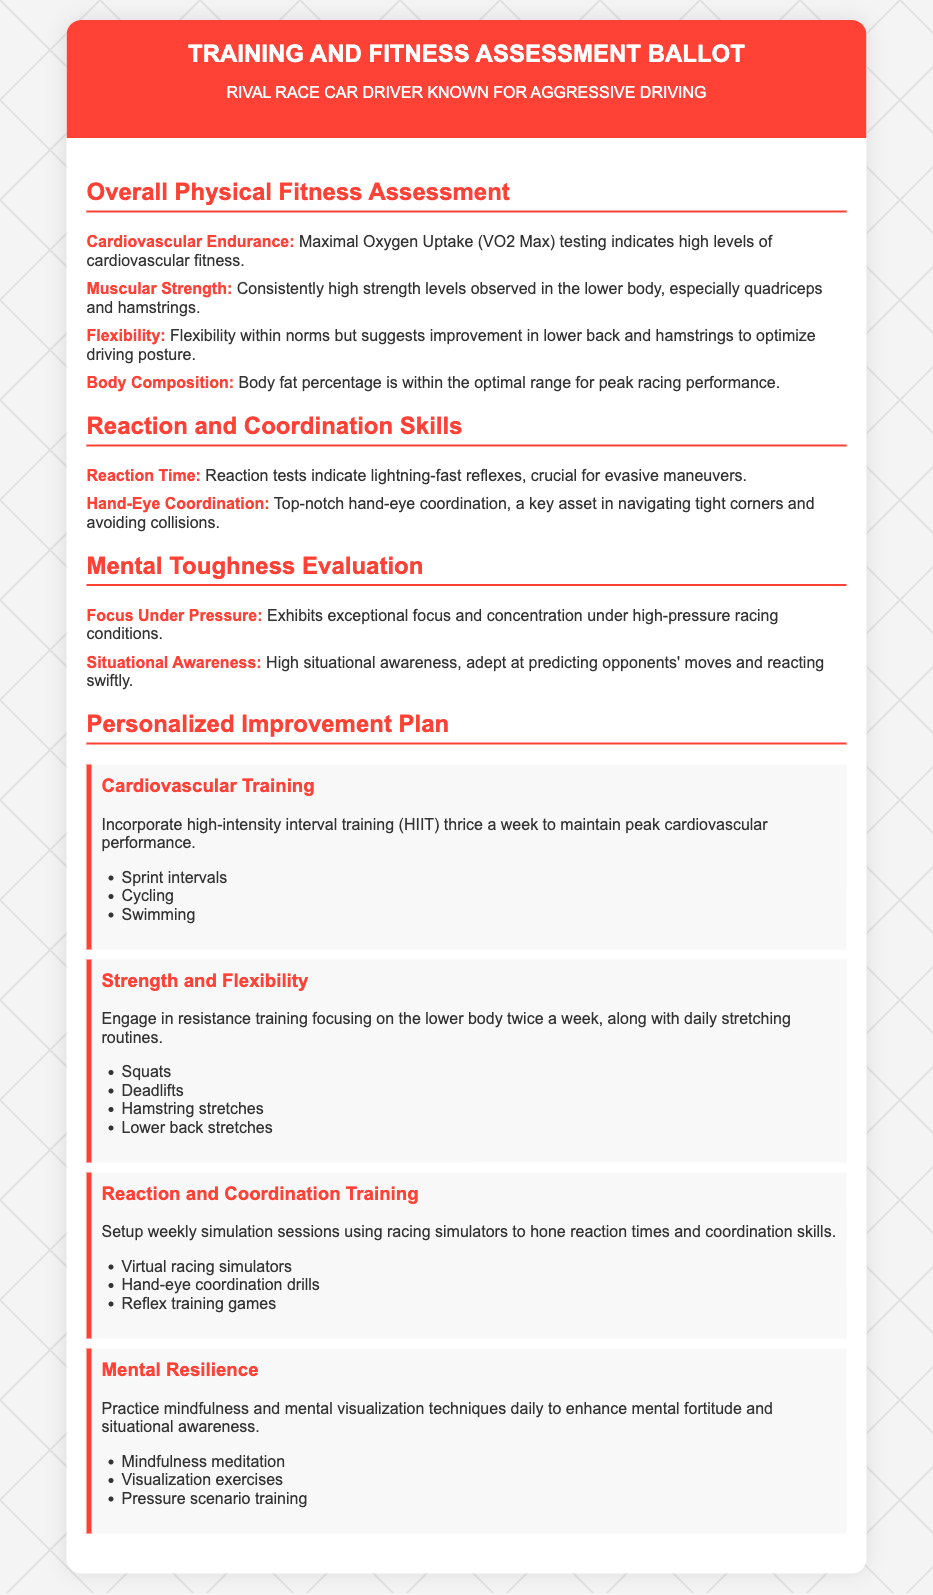What is the title of the document? The title is found in the header of the document and represents the main focus.
Answer: Training and Fitness Assessment Ballot What is highlighted as a strength in muscular strength? This is an assessment observation noted in the document about overall fitness.
Answer: Lower body What type of flexibility is suggested for improvement? This reflects recommendations made in the flexibility assessment section of the document.
Answer: Lower back and hamstrings How many times a week should high-intensity interval training be incorporated? This detail is part of the personalized improvement plan for cardiovascular training.
Answer: Thrice What does the improvement plan suggest for strengthening flexibility? This is about the plan derived from the fitness assessment findings.
Answer: Daily stretching routines What technique is recommended for practicing mental resilience? This is a specific recommendation listed under the mental resilience section of the personalized improvement plan.
Answer: Mindfulness meditation What assessment item indicates a measure of quick reflexes? This distinguishes the capability from another part of the overall fitness evaluation section.
Answer: Reaction Time Which activity is included for coordination training? This is specified in the improvement plan related to enhancing training skills.
Answer: Virtual racing simulators How is body composition described in the assessment? This observation relates to the overall fitness evaluation and defines a critical aspect.
Answer: Optimal range for peak racing performance 